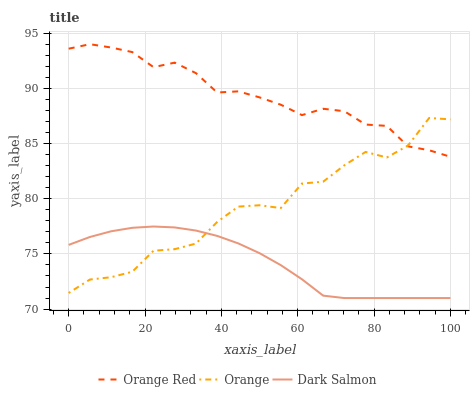Does Dark Salmon have the minimum area under the curve?
Answer yes or no. Yes. Does Orange Red have the maximum area under the curve?
Answer yes or no. Yes. Does Orange Red have the minimum area under the curve?
Answer yes or no. No. Does Dark Salmon have the maximum area under the curve?
Answer yes or no. No. Is Dark Salmon the smoothest?
Answer yes or no. Yes. Is Orange the roughest?
Answer yes or no. Yes. Is Orange Red the smoothest?
Answer yes or no. No. Is Orange Red the roughest?
Answer yes or no. No. Does Dark Salmon have the lowest value?
Answer yes or no. Yes. Does Orange Red have the lowest value?
Answer yes or no. No. Does Orange Red have the highest value?
Answer yes or no. Yes. Does Dark Salmon have the highest value?
Answer yes or no. No. Is Dark Salmon less than Orange Red?
Answer yes or no. Yes. Is Orange Red greater than Dark Salmon?
Answer yes or no. Yes. Does Dark Salmon intersect Orange?
Answer yes or no. Yes. Is Dark Salmon less than Orange?
Answer yes or no. No. Is Dark Salmon greater than Orange?
Answer yes or no. No. Does Dark Salmon intersect Orange Red?
Answer yes or no. No. 